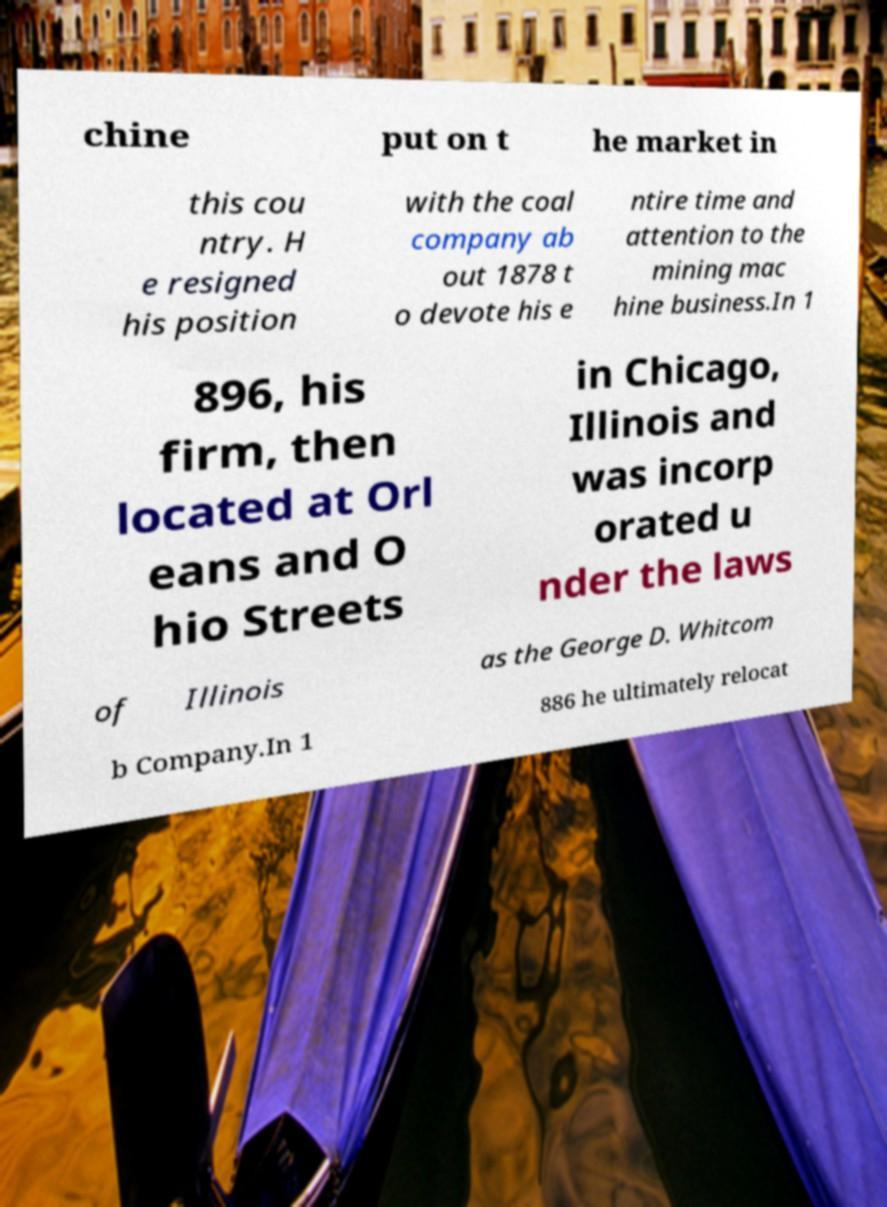I need the written content from this picture converted into text. Can you do that? chine put on t he market in this cou ntry. H e resigned his position with the coal company ab out 1878 t o devote his e ntire time and attention to the mining mac hine business.In 1 896, his firm, then located at Orl eans and O hio Streets in Chicago, Illinois and was incorp orated u nder the laws of Illinois as the George D. Whitcom b Company.In 1 886 he ultimately relocat 